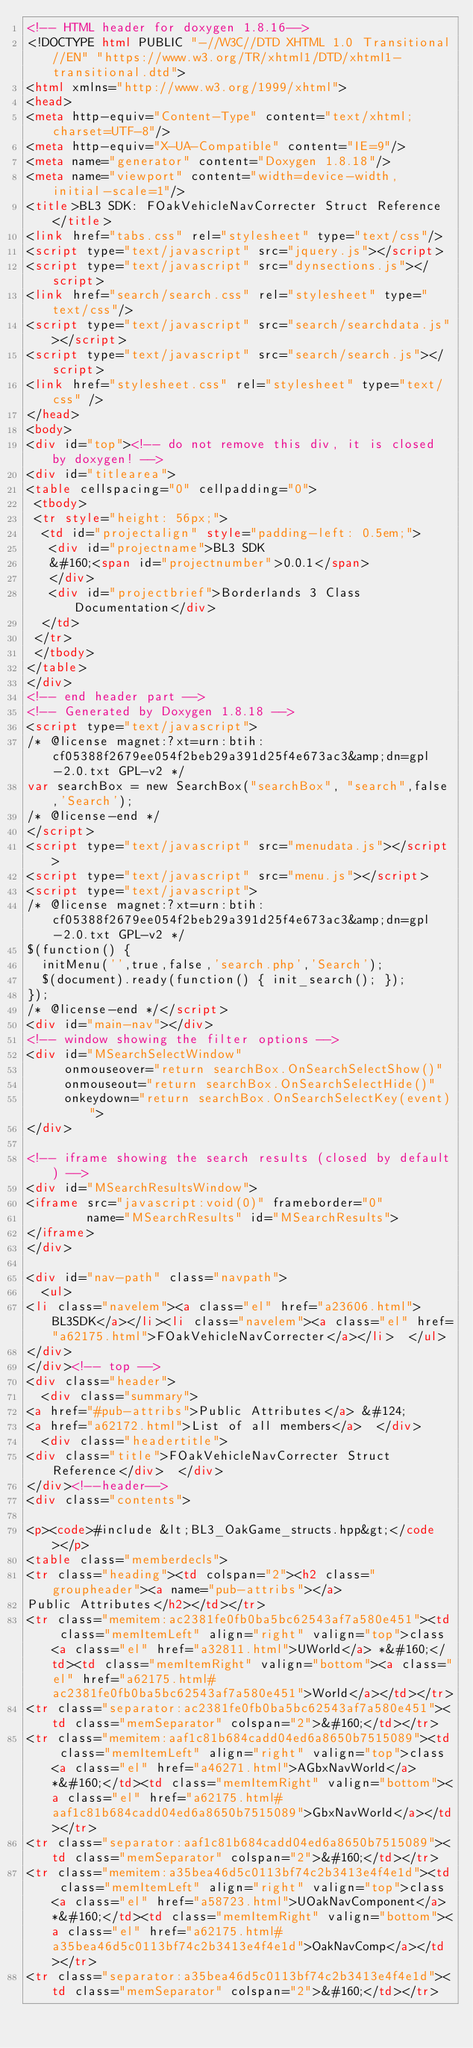<code> <loc_0><loc_0><loc_500><loc_500><_HTML_><!-- HTML header for doxygen 1.8.16-->
<!DOCTYPE html PUBLIC "-//W3C//DTD XHTML 1.0 Transitional//EN" "https://www.w3.org/TR/xhtml1/DTD/xhtml1-transitional.dtd">
<html xmlns="http://www.w3.org/1999/xhtml">
<head>
<meta http-equiv="Content-Type" content="text/xhtml;charset=UTF-8"/>
<meta http-equiv="X-UA-Compatible" content="IE=9"/>
<meta name="generator" content="Doxygen 1.8.18"/>
<meta name="viewport" content="width=device-width, initial-scale=1"/>
<title>BL3 SDK: FOakVehicleNavCorrecter Struct Reference</title>
<link href="tabs.css" rel="stylesheet" type="text/css"/>
<script type="text/javascript" src="jquery.js"></script>
<script type="text/javascript" src="dynsections.js"></script>
<link href="search/search.css" rel="stylesheet" type="text/css"/>
<script type="text/javascript" src="search/searchdata.js"></script>
<script type="text/javascript" src="search/search.js"></script>
<link href="stylesheet.css" rel="stylesheet" type="text/css" />
</head>
<body>
<div id="top"><!-- do not remove this div, it is closed by doxygen! -->
<div id="titlearea">
<table cellspacing="0" cellpadding="0">
 <tbody>
 <tr style="height: 56px;">
  <td id="projectalign" style="padding-left: 0.5em;">
   <div id="projectname">BL3 SDK
   &#160;<span id="projectnumber">0.0.1</span>
   </div>
   <div id="projectbrief">Borderlands 3 Class Documentation</div>
  </td>
 </tr>
 </tbody>
</table>
</div>
<!-- end header part -->
<!-- Generated by Doxygen 1.8.18 -->
<script type="text/javascript">
/* @license magnet:?xt=urn:btih:cf05388f2679ee054f2beb29a391d25f4e673ac3&amp;dn=gpl-2.0.txt GPL-v2 */
var searchBox = new SearchBox("searchBox", "search",false,'Search');
/* @license-end */
</script>
<script type="text/javascript" src="menudata.js"></script>
<script type="text/javascript" src="menu.js"></script>
<script type="text/javascript">
/* @license magnet:?xt=urn:btih:cf05388f2679ee054f2beb29a391d25f4e673ac3&amp;dn=gpl-2.0.txt GPL-v2 */
$(function() {
  initMenu('',true,false,'search.php','Search');
  $(document).ready(function() { init_search(); });
});
/* @license-end */</script>
<div id="main-nav"></div>
<!-- window showing the filter options -->
<div id="MSearchSelectWindow"
     onmouseover="return searchBox.OnSearchSelectShow()"
     onmouseout="return searchBox.OnSearchSelectHide()"
     onkeydown="return searchBox.OnSearchSelectKey(event)">
</div>

<!-- iframe showing the search results (closed by default) -->
<div id="MSearchResultsWindow">
<iframe src="javascript:void(0)" frameborder="0" 
        name="MSearchResults" id="MSearchResults">
</iframe>
</div>

<div id="nav-path" class="navpath">
  <ul>
<li class="navelem"><a class="el" href="a23606.html">BL3SDK</a></li><li class="navelem"><a class="el" href="a62175.html">FOakVehicleNavCorrecter</a></li>  </ul>
</div>
</div><!-- top -->
<div class="header">
  <div class="summary">
<a href="#pub-attribs">Public Attributes</a> &#124;
<a href="a62172.html">List of all members</a>  </div>
  <div class="headertitle">
<div class="title">FOakVehicleNavCorrecter Struct Reference</div>  </div>
</div><!--header-->
<div class="contents">

<p><code>#include &lt;BL3_OakGame_structs.hpp&gt;</code></p>
<table class="memberdecls">
<tr class="heading"><td colspan="2"><h2 class="groupheader"><a name="pub-attribs"></a>
Public Attributes</h2></td></tr>
<tr class="memitem:ac2381fe0fb0ba5bc62543af7a580e451"><td class="memItemLeft" align="right" valign="top">class <a class="el" href="a32811.html">UWorld</a> *&#160;</td><td class="memItemRight" valign="bottom"><a class="el" href="a62175.html#ac2381fe0fb0ba5bc62543af7a580e451">World</a></td></tr>
<tr class="separator:ac2381fe0fb0ba5bc62543af7a580e451"><td class="memSeparator" colspan="2">&#160;</td></tr>
<tr class="memitem:aaf1c81b684cadd04ed6a8650b7515089"><td class="memItemLeft" align="right" valign="top">class <a class="el" href="a46271.html">AGbxNavWorld</a> *&#160;</td><td class="memItemRight" valign="bottom"><a class="el" href="a62175.html#aaf1c81b684cadd04ed6a8650b7515089">GbxNavWorld</a></td></tr>
<tr class="separator:aaf1c81b684cadd04ed6a8650b7515089"><td class="memSeparator" colspan="2">&#160;</td></tr>
<tr class="memitem:a35bea46d5c0113bf74c2b3413e4f4e1d"><td class="memItemLeft" align="right" valign="top">class <a class="el" href="a58723.html">UOakNavComponent</a> *&#160;</td><td class="memItemRight" valign="bottom"><a class="el" href="a62175.html#a35bea46d5c0113bf74c2b3413e4f4e1d">OakNavComp</a></td></tr>
<tr class="separator:a35bea46d5c0113bf74c2b3413e4f4e1d"><td class="memSeparator" colspan="2">&#160;</td></tr></code> 